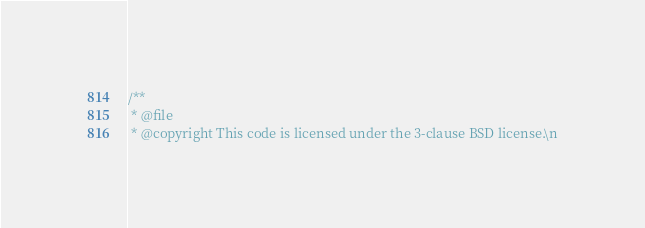Convert code to text. <code><loc_0><loc_0><loc_500><loc_500><_C++_>/**
 * @file
 * @copyright This code is licensed under the 3-clause BSD license.\n</code> 